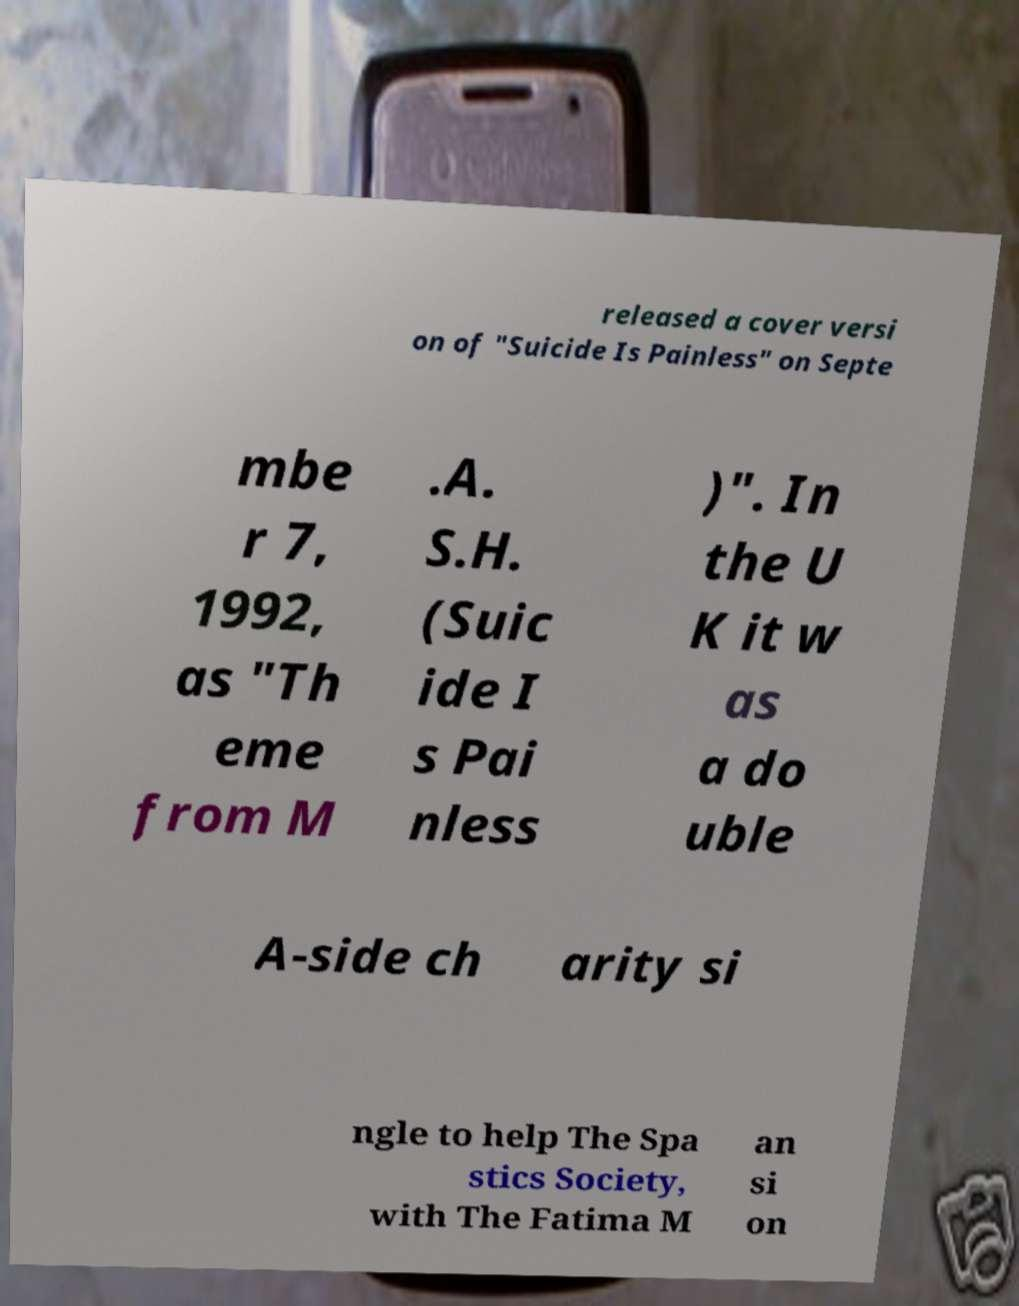There's text embedded in this image that I need extracted. Can you transcribe it verbatim? released a cover versi on of "Suicide Is Painless" on Septe mbe r 7, 1992, as "Th eme from M .A. S.H. (Suic ide I s Pai nless )". In the U K it w as a do uble A-side ch arity si ngle to help The Spa stics Society, with The Fatima M an si on 